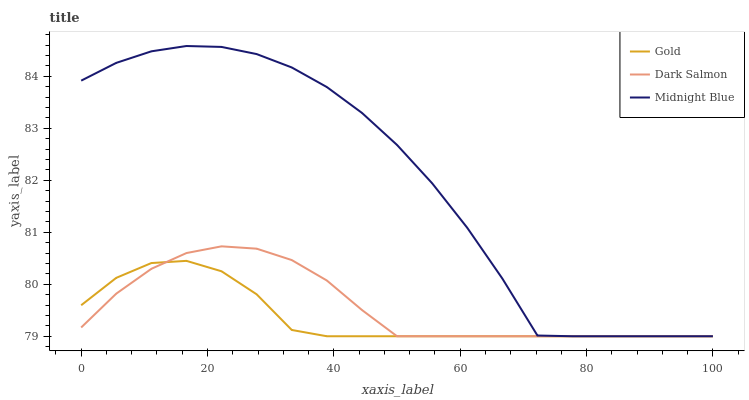Does Gold have the minimum area under the curve?
Answer yes or no. Yes. Does Midnight Blue have the maximum area under the curve?
Answer yes or no. Yes. Does Midnight Blue have the minimum area under the curve?
Answer yes or no. No. Does Gold have the maximum area under the curve?
Answer yes or no. No. Is Dark Salmon the smoothest?
Answer yes or no. Yes. Is Midnight Blue the roughest?
Answer yes or no. Yes. Is Gold the smoothest?
Answer yes or no. No. Is Gold the roughest?
Answer yes or no. No. Does Dark Salmon have the lowest value?
Answer yes or no. Yes. Does Midnight Blue have the highest value?
Answer yes or no. Yes. Does Gold have the highest value?
Answer yes or no. No. Does Gold intersect Dark Salmon?
Answer yes or no. Yes. Is Gold less than Dark Salmon?
Answer yes or no. No. Is Gold greater than Dark Salmon?
Answer yes or no. No. 